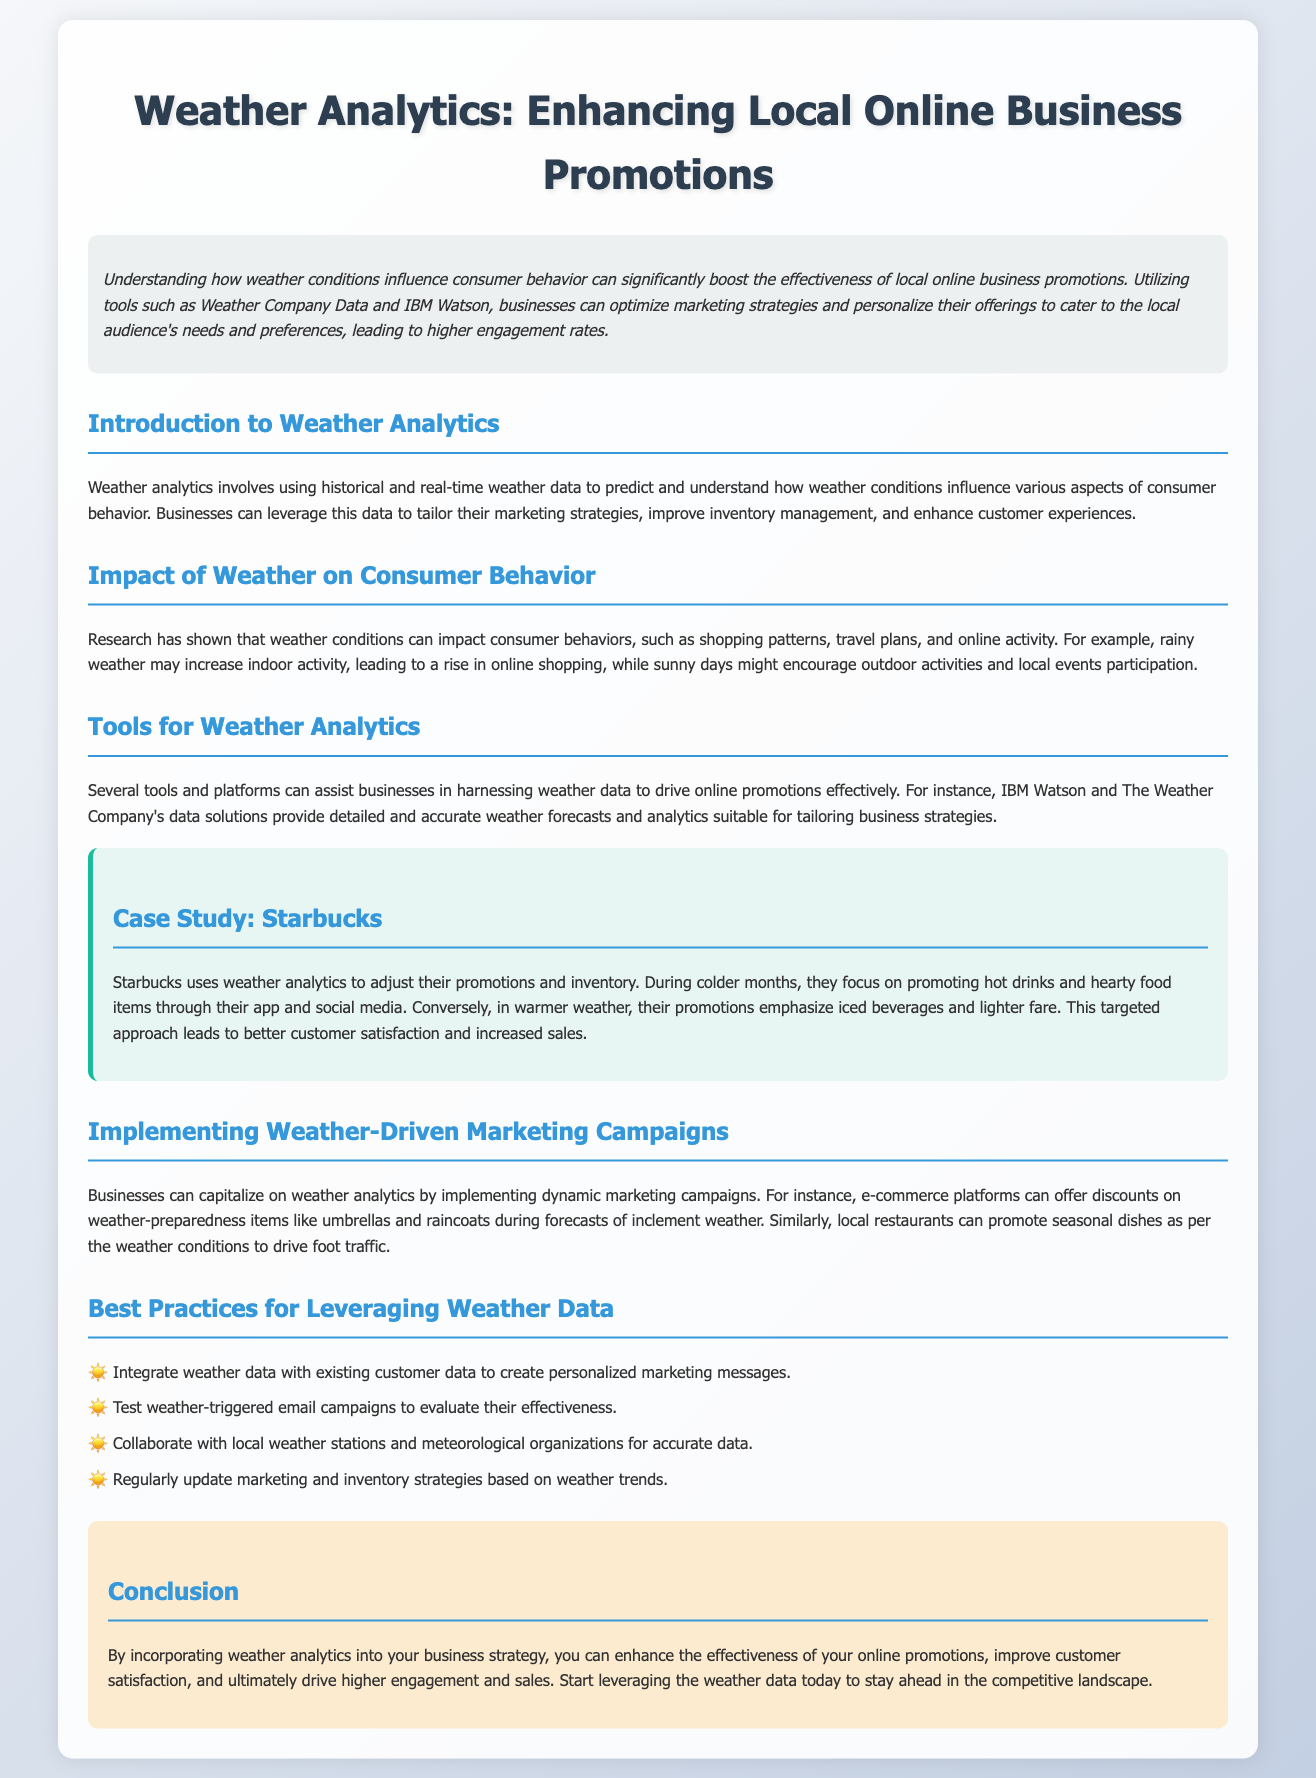What is the title of the document? The title of the document is presented at the top in a large font.
Answer: Weather Analytics: Enhancing Local Online Business Promotions What company is mentioned in the case study? The case study in the document specifically highlights a well-known coffee brand.
Answer: Starbucks What tool is suggested for leveraging weather data? The document recommends a specific AI platform for weather data analysis.
Answer: IBM Watson How does Starbucks adjust its promotions in colder months? The document describes how Starbucks tailors its offerings based on seasonal weather changes, particularly in colder periods.
Answer: Promoting hot drinks What is one of the best practices listed for leveraging weather data? The document includes a list of practices to effectively use weather analytics for marketing.
Answer: Integrate weather data with existing customer data What weather condition increases online shopping activity according to the document? The document specifies a weather condition that leads to higher online consumer behavior.
Answer: Rainy weather What color is used for the section headers in the document? The color scheme for section headers and titles is mentioned in the styling of the document layout.
Answer: Blue How can restaurants use weather data according to the recommendations? The document describes a tactic for local dining businesses to boost customer visits based on the weather.
Answer: Promote seasonal dishes 